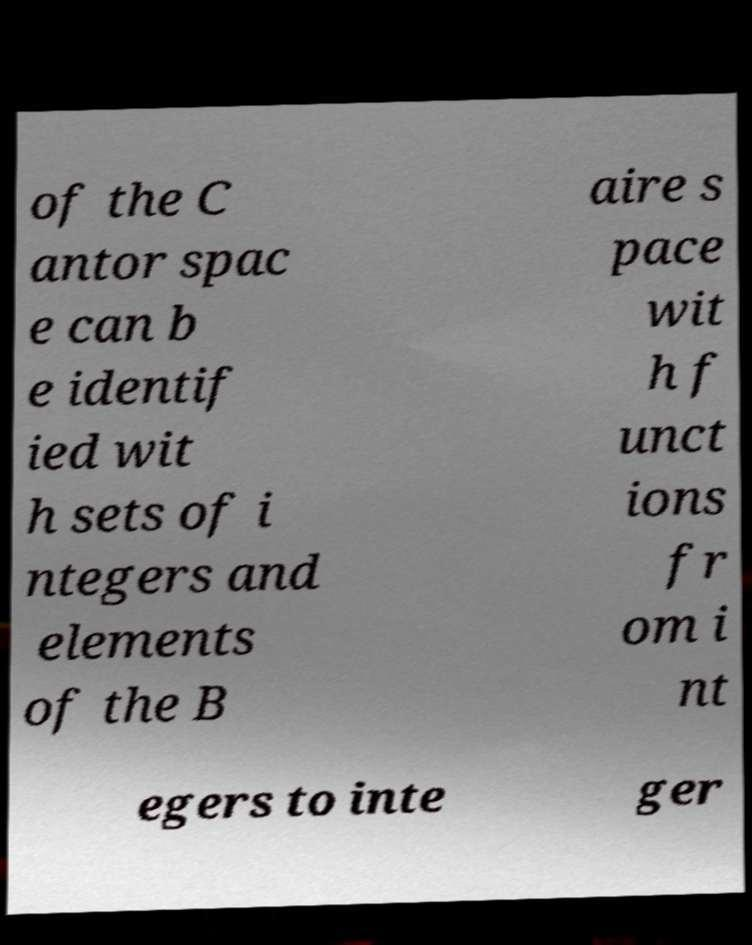Can you accurately transcribe the text from the provided image for me? of the C antor spac e can b e identif ied wit h sets of i ntegers and elements of the B aire s pace wit h f unct ions fr om i nt egers to inte ger 